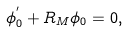<formula> <loc_0><loc_0><loc_500><loc_500>\phi ^ { ^ { \prime } } _ { 0 } + R _ { M } \phi _ { 0 } = 0 ,</formula> 